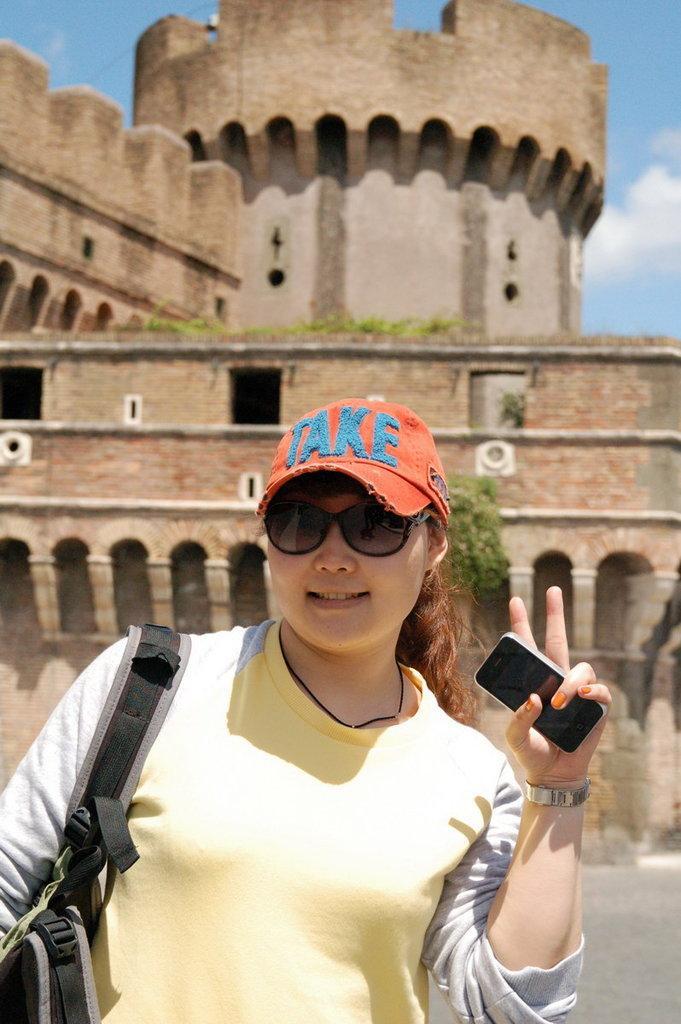Describe this image in one or two sentences. This picture is of outside. In the center there is a Woman wearing yellow color t-shirt, a backpack and a hat, holding a mobile phone and standing. In the background we can see a Castle, sky, ground and some clouds in the sky. 